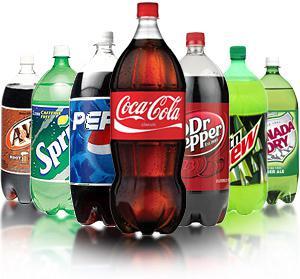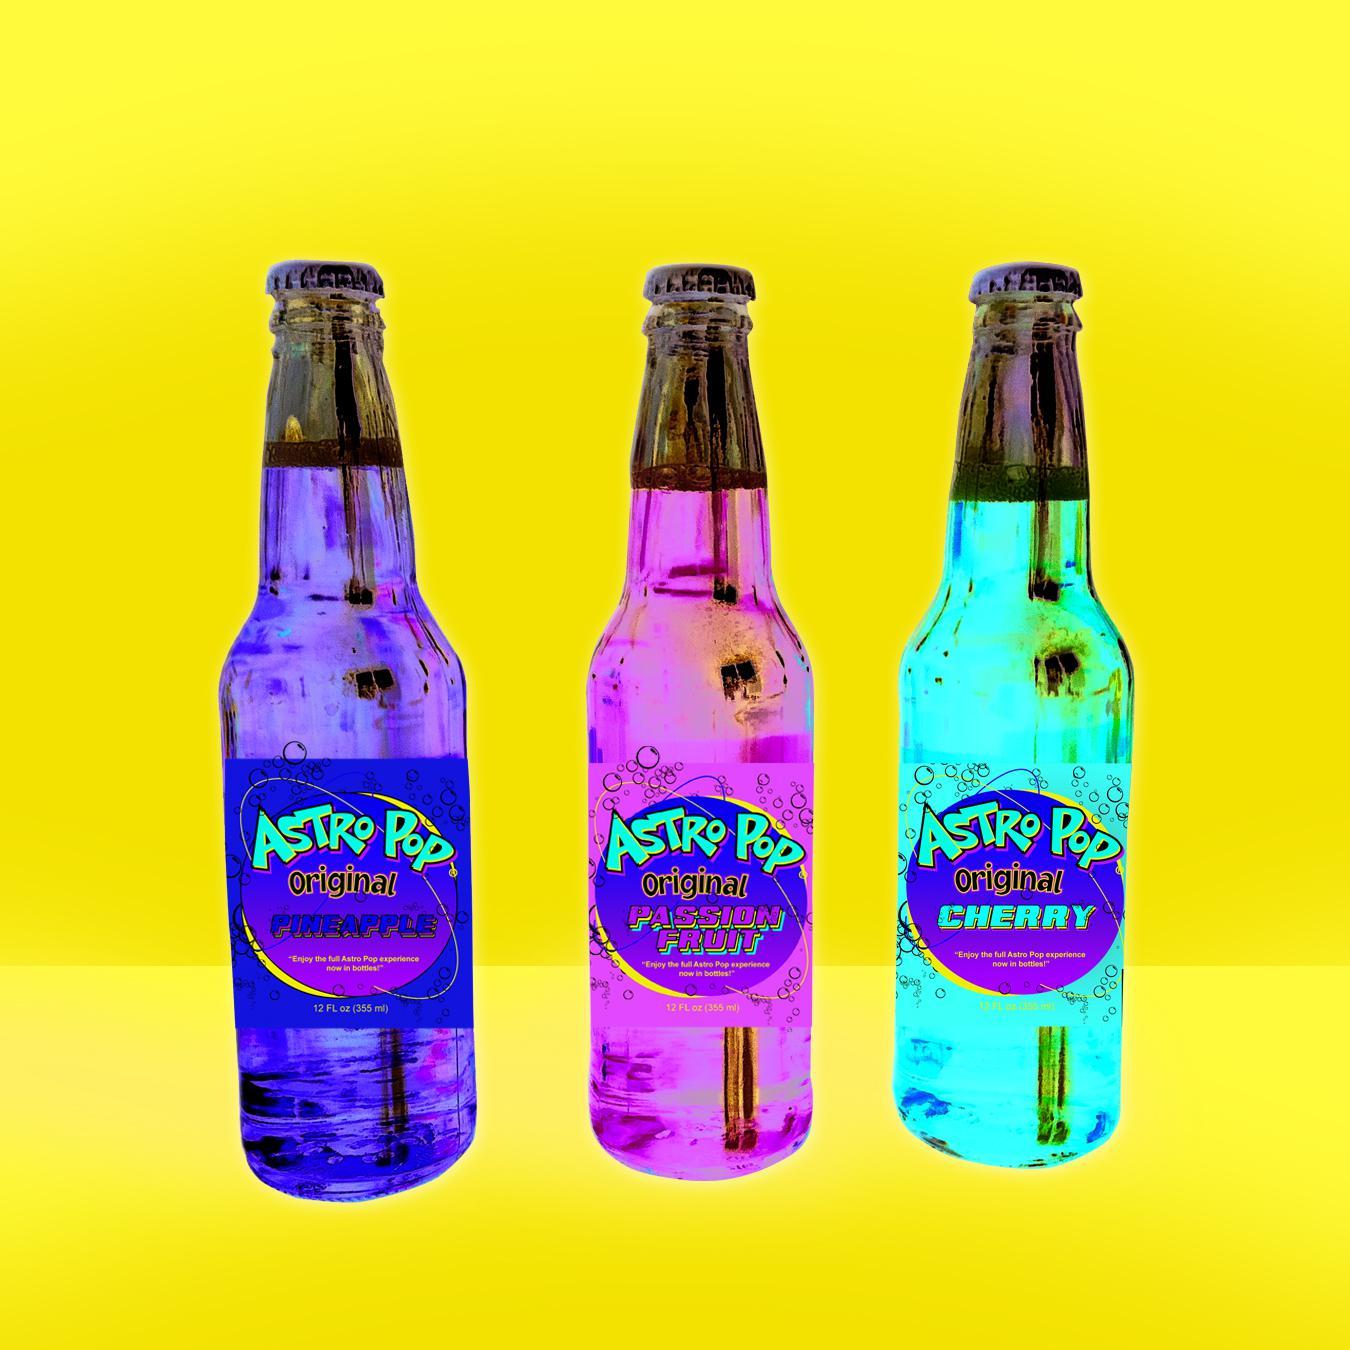The first image is the image on the left, the second image is the image on the right. Assess this claim about the two images: "There is a total of six bottles". Correct or not? Answer yes or no. No. The first image is the image on the left, the second image is the image on the right. For the images shown, is this caption "There are the same number of bottles in each of the images." true? Answer yes or no. No. 